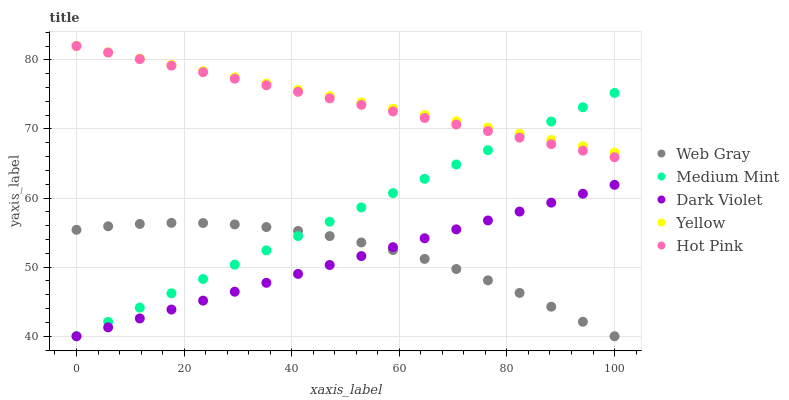Does Dark Violet have the minimum area under the curve?
Answer yes or no. Yes. Does Yellow have the maximum area under the curve?
Answer yes or no. Yes. Does Web Gray have the minimum area under the curve?
Answer yes or no. No. Does Web Gray have the maximum area under the curve?
Answer yes or no. No. Is Hot Pink the smoothest?
Answer yes or no. Yes. Is Web Gray the roughest?
Answer yes or no. Yes. Is Yellow the smoothest?
Answer yes or no. No. Is Yellow the roughest?
Answer yes or no. No. Does Medium Mint have the lowest value?
Answer yes or no. Yes. Does Yellow have the lowest value?
Answer yes or no. No. Does Hot Pink have the highest value?
Answer yes or no. Yes. Does Web Gray have the highest value?
Answer yes or no. No. Is Web Gray less than Hot Pink?
Answer yes or no. Yes. Is Yellow greater than Dark Violet?
Answer yes or no. Yes. Does Medium Mint intersect Dark Violet?
Answer yes or no. Yes. Is Medium Mint less than Dark Violet?
Answer yes or no. No. Is Medium Mint greater than Dark Violet?
Answer yes or no. No. Does Web Gray intersect Hot Pink?
Answer yes or no. No. 